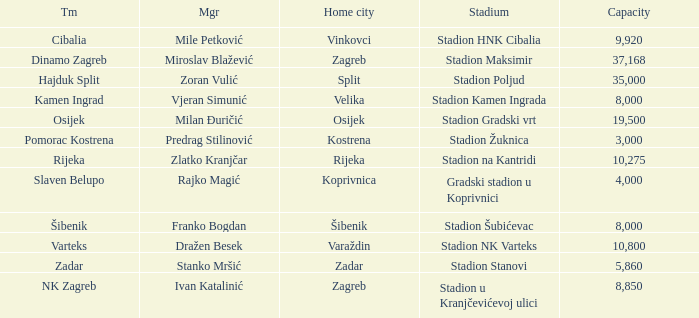What team has a home city of Velika? Kamen Ingrad. 